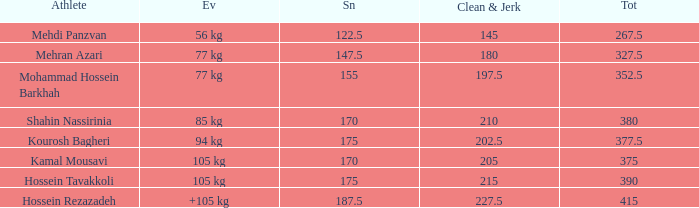What is the total that had an event of +105 kg and clean & jerk less than 227.5? 0.0. 